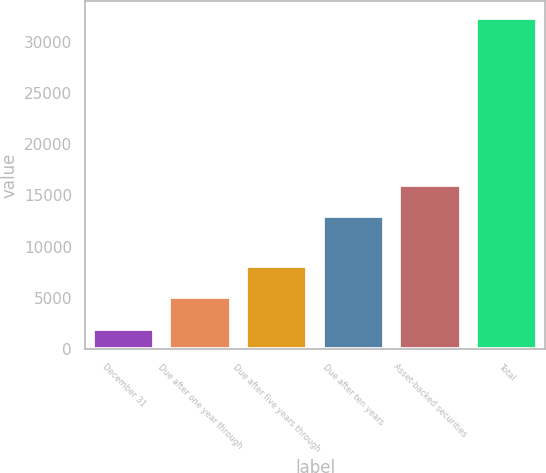<chart> <loc_0><loc_0><loc_500><loc_500><bar_chart><fcel>December 31<fcel>Due after one year through<fcel>Due after five years through<fcel>Due after ten years<fcel>Asset-backed securities<fcel>Total<nl><fcel>2005<fcel>5039.24<fcel>8073.48<fcel>12973.9<fcel>16008.1<fcel>32347.4<nl></chart> 